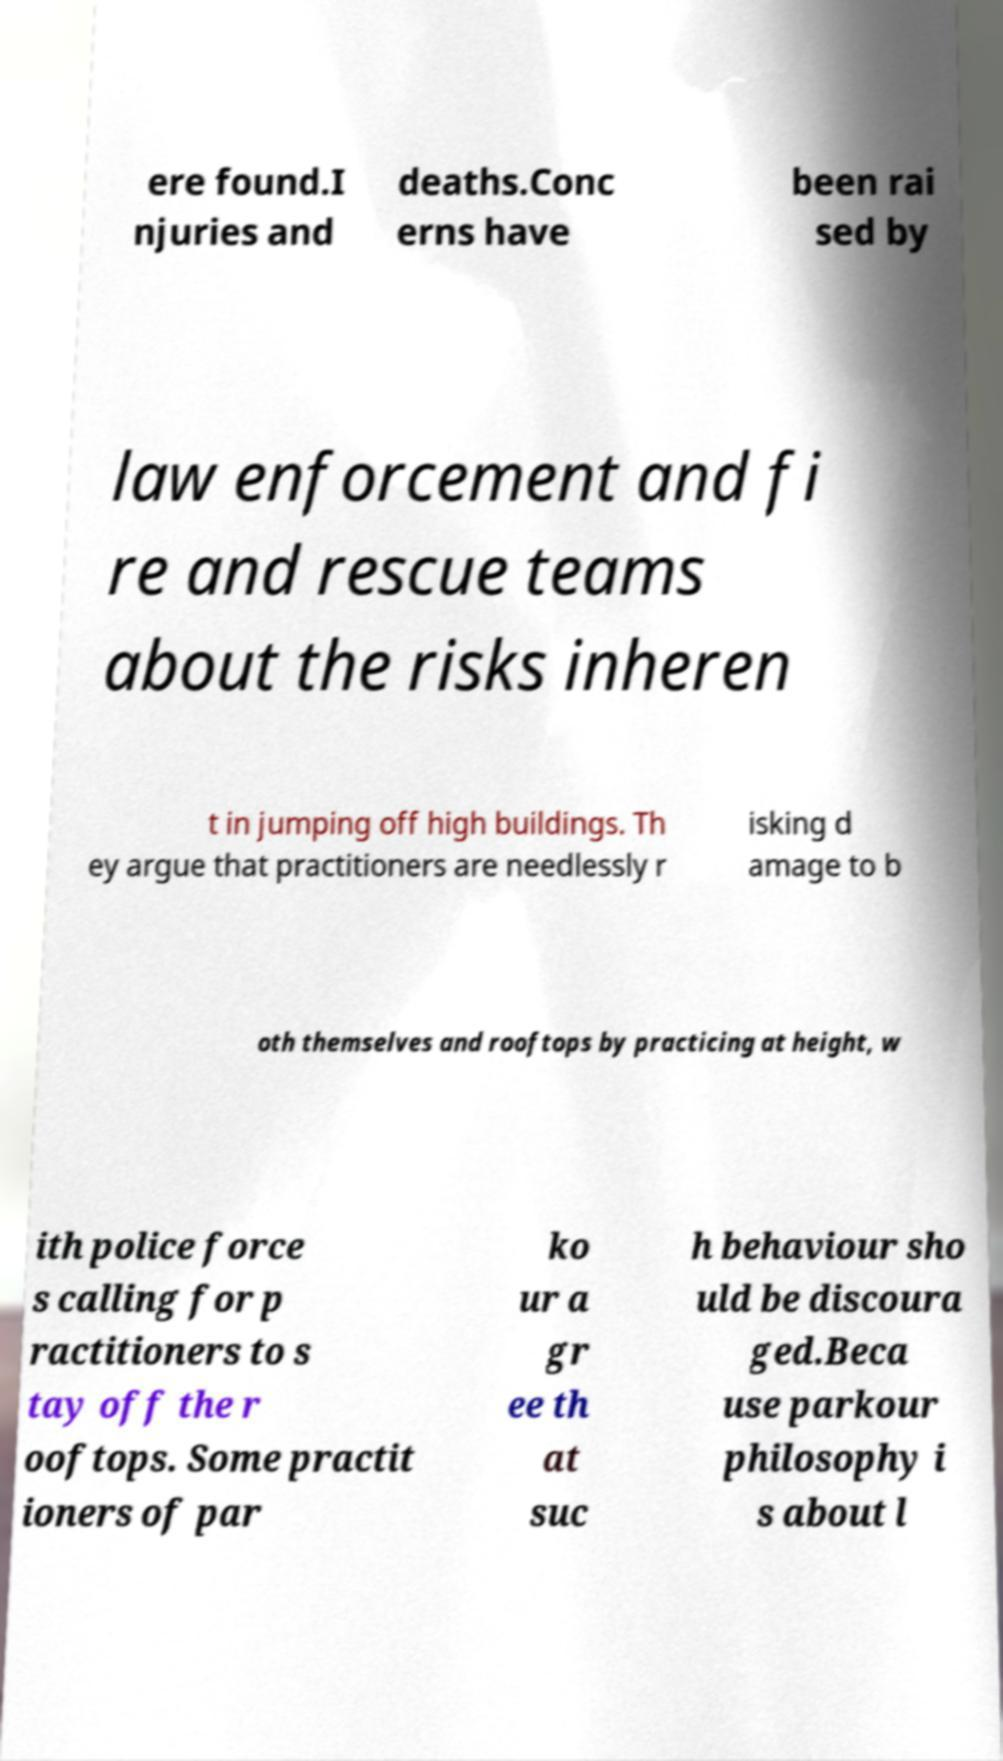I need the written content from this picture converted into text. Can you do that? ere found.I njuries and deaths.Conc erns have been rai sed by law enforcement and fi re and rescue teams about the risks inheren t in jumping off high buildings. Th ey argue that practitioners are needlessly r isking d amage to b oth themselves and rooftops by practicing at height, w ith police force s calling for p ractitioners to s tay off the r ooftops. Some practit ioners of par ko ur a gr ee th at suc h behaviour sho uld be discoura ged.Beca use parkour philosophy i s about l 